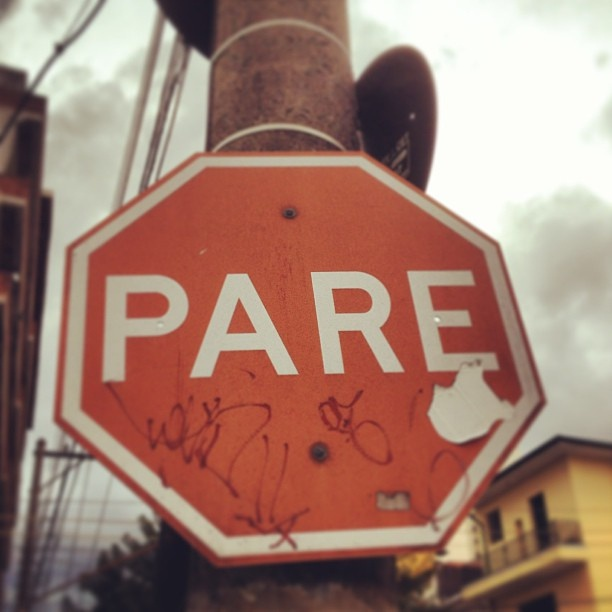Describe the objects in this image and their specific colors. I can see a stop sign in gray, brown, and tan tones in this image. 